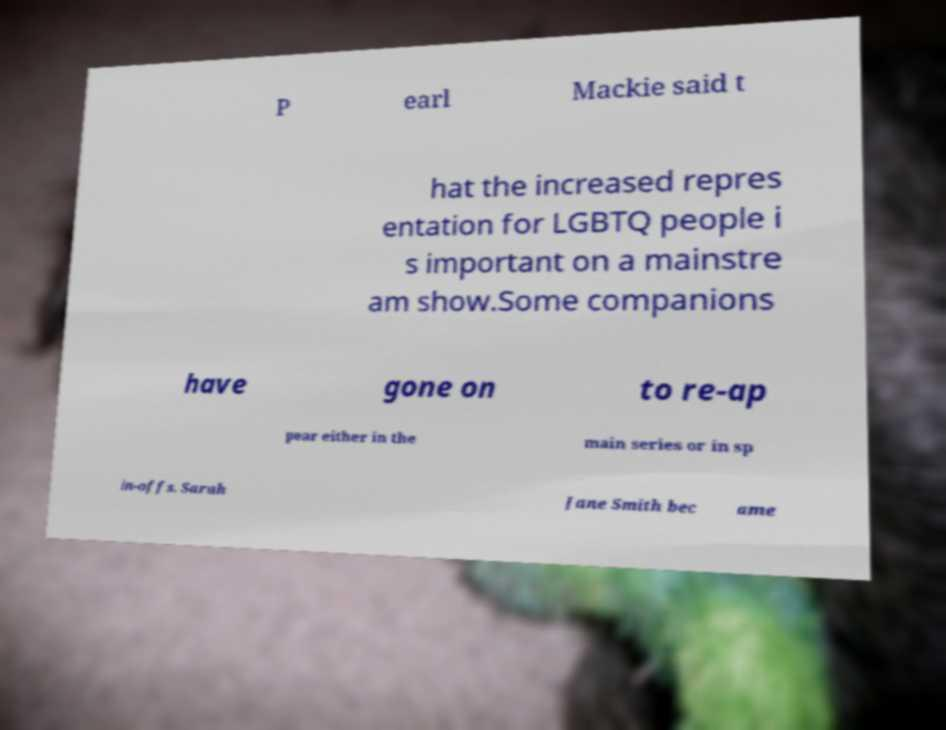Could you extract and type out the text from this image? P earl Mackie said t hat the increased repres entation for LGBTQ people i s important on a mainstre am show.Some companions have gone on to re-ap pear either in the main series or in sp in-offs. Sarah Jane Smith bec ame 